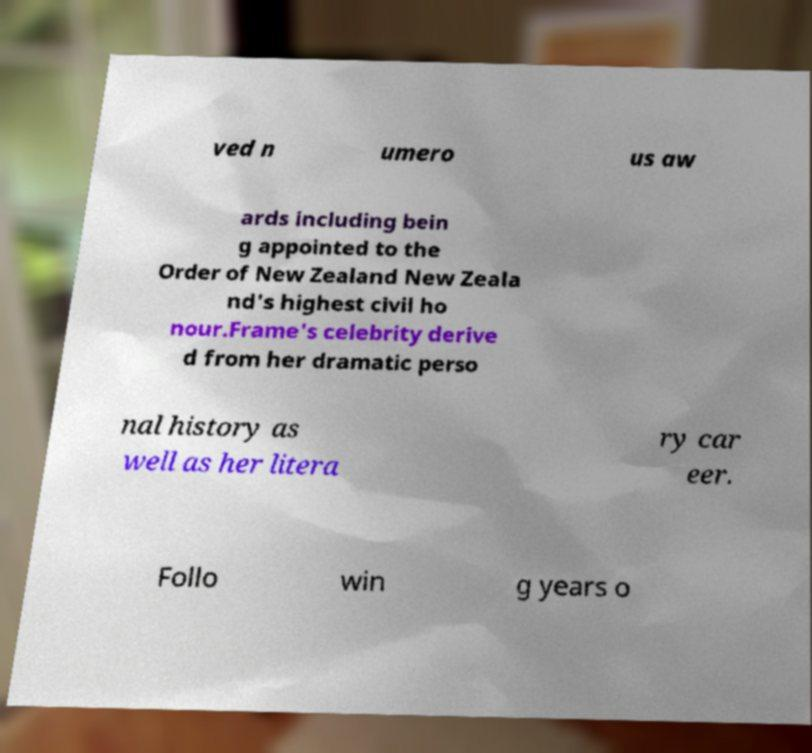Please read and relay the text visible in this image. What does it say? ved n umero us aw ards including bein g appointed to the Order of New Zealand New Zeala nd's highest civil ho nour.Frame's celebrity derive d from her dramatic perso nal history as well as her litera ry car eer. Follo win g years o 